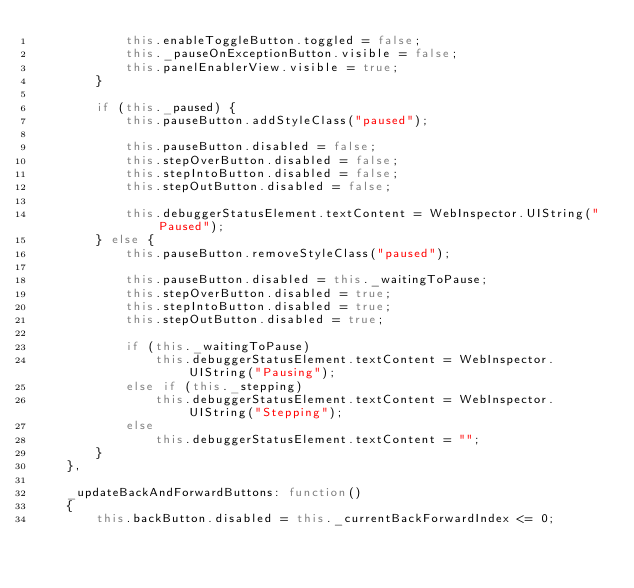Convert code to text. <code><loc_0><loc_0><loc_500><loc_500><_JavaScript_>            this.enableToggleButton.toggled = false;
            this._pauseOnExceptionButton.visible = false;
            this.panelEnablerView.visible = true;
        }

        if (this._paused) {
            this.pauseButton.addStyleClass("paused");

            this.pauseButton.disabled = false;
            this.stepOverButton.disabled = false;
            this.stepIntoButton.disabled = false;
            this.stepOutButton.disabled = false;

            this.debuggerStatusElement.textContent = WebInspector.UIString("Paused");
        } else {
            this.pauseButton.removeStyleClass("paused");

            this.pauseButton.disabled = this._waitingToPause;
            this.stepOverButton.disabled = true;
            this.stepIntoButton.disabled = true;
            this.stepOutButton.disabled = true;

            if (this._waitingToPause)
                this.debuggerStatusElement.textContent = WebInspector.UIString("Pausing");
            else if (this._stepping)
                this.debuggerStatusElement.textContent = WebInspector.UIString("Stepping");
            else
                this.debuggerStatusElement.textContent = "";
        }
    },

    _updateBackAndForwardButtons: function()
    {
        this.backButton.disabled = this._currentBackForwardIndex <= 0;</code> 